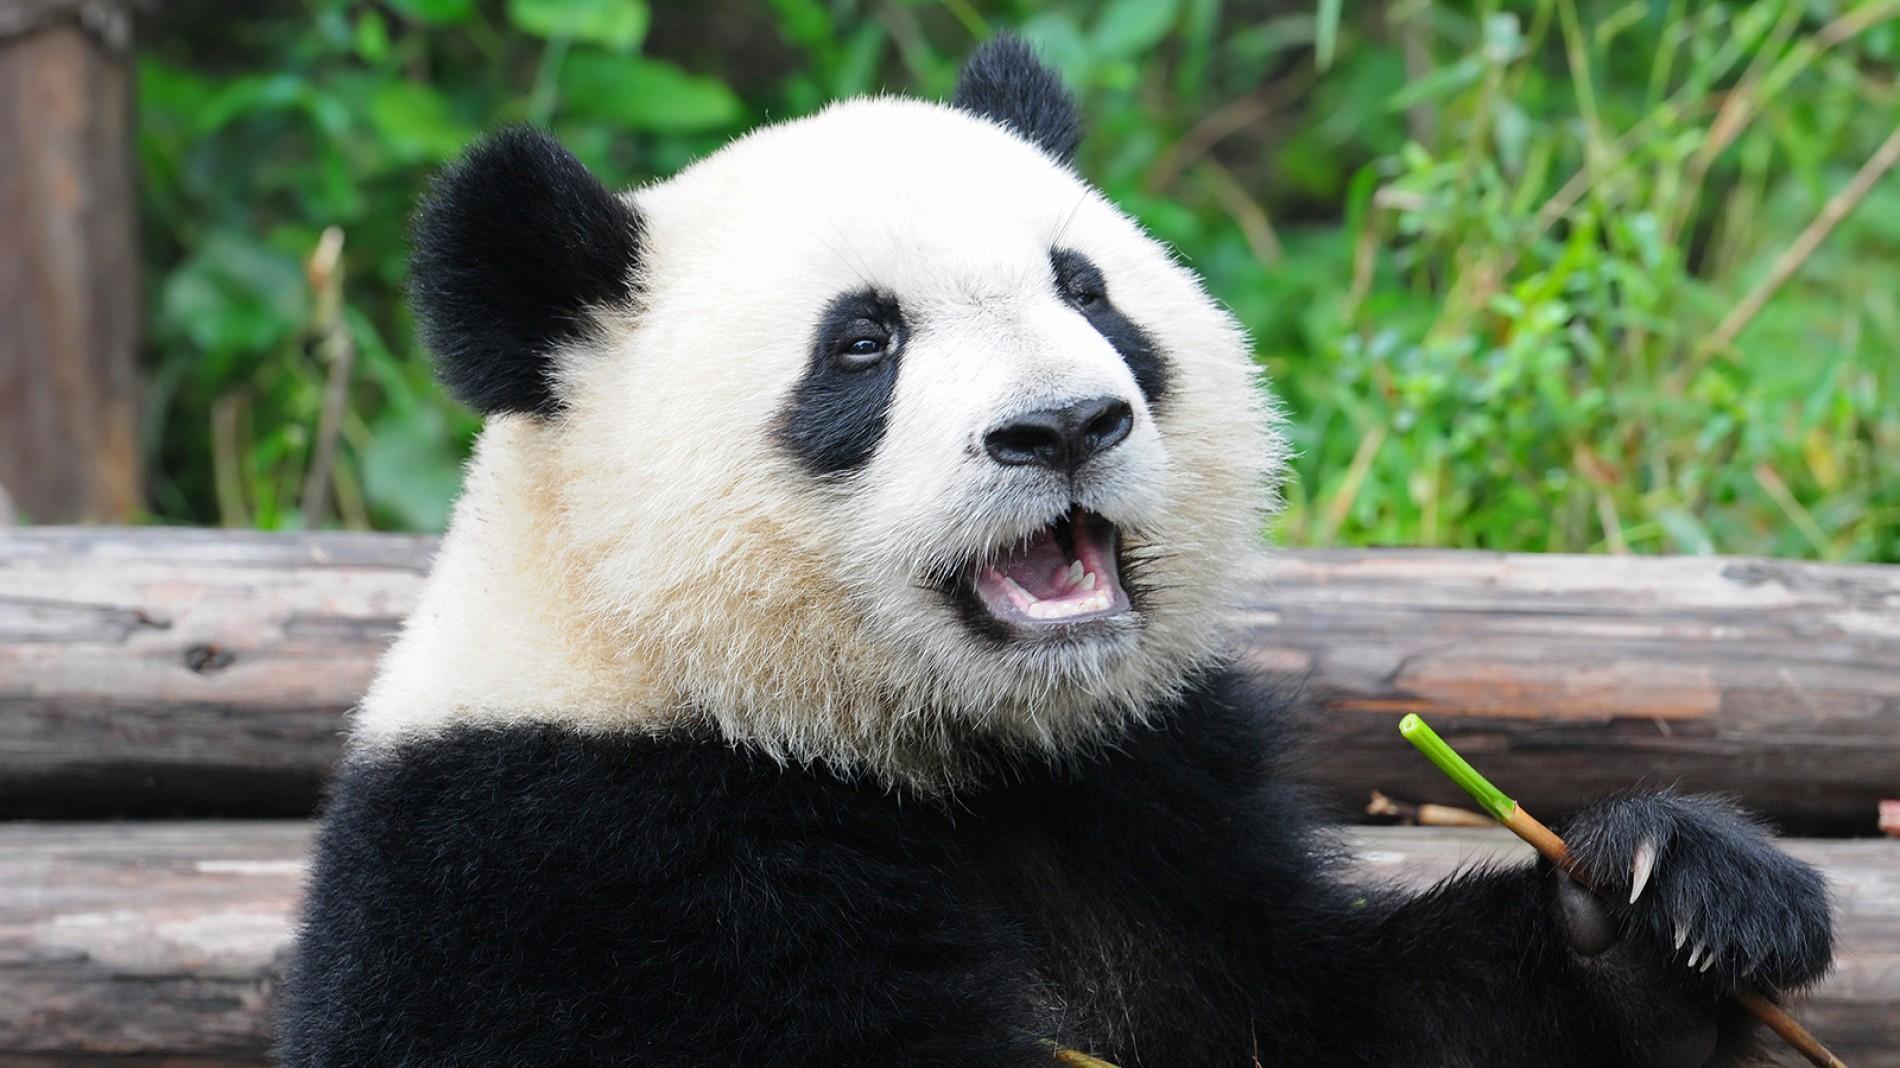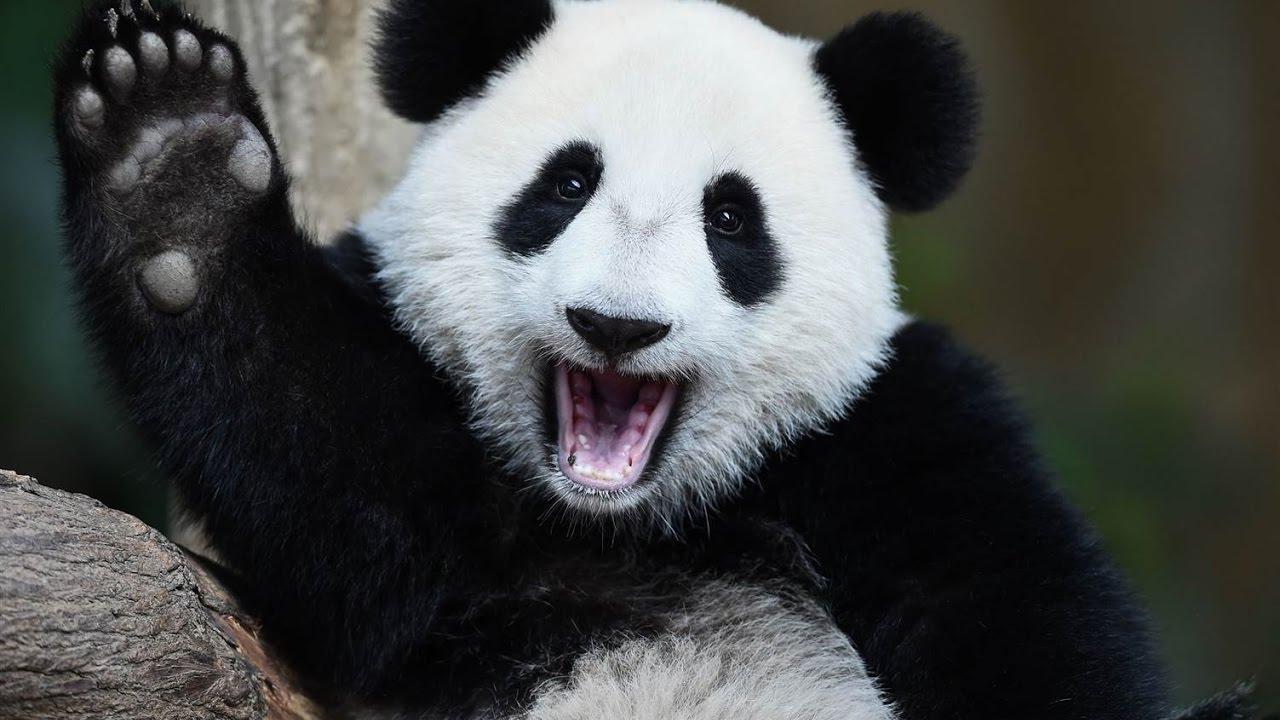The first image is the image on the left, the second image is the image on the right. Given the left and right images, does the statement "An image shows an adult panda on its back, playing with a young panda on top." hold true? Answer yes or no. No. The first image is the image on the left, the second image is the image on the right. Given the left and right images, does the statement "There are three panda bears" hold true? Answer yes or no. No. 